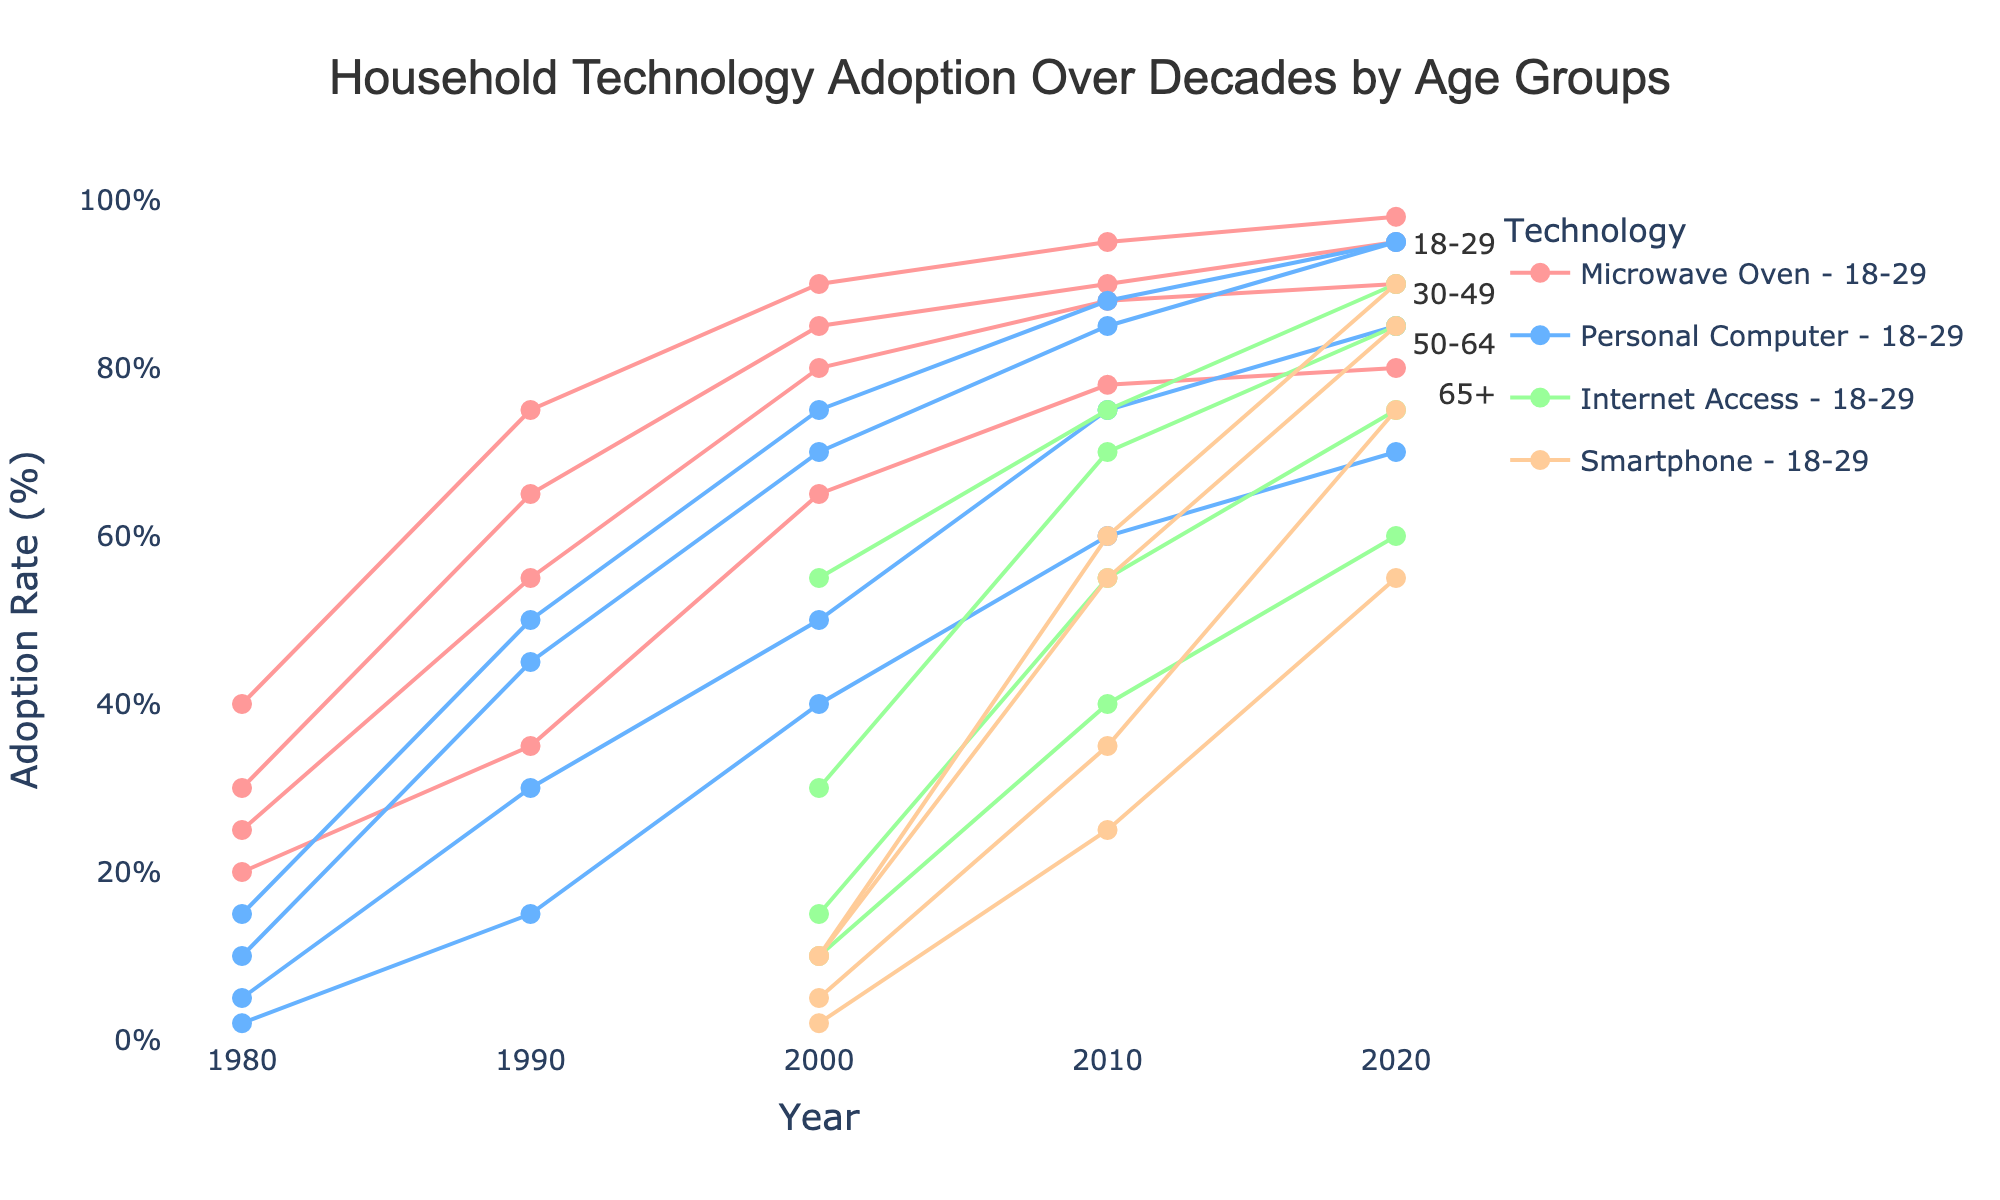What year shows the highest adoption rate for smartphones among 18-29-year-olds? By looking at the Ranged Dot Plot, identify the year label on the x-axis where the data point for 18-29-year-olds and smartphones is at its highest position on the y-axis.
Answer: 2020 What is the main title of the figure? Locate the text at the top center of the plot to find the main title.
Answer: Household Technology Adoption Over Decades by Age Groups Which technology had the lowest adoption rate in 2000 within the 65+ age group? Look at the data points for each technology in the year 2000 corresponding to the 65+ age group. Identify the one with the lowest position on the y-axis.
Answer: Personal Computer How did the adoption rate of microwave ovens in the 30-49 age group change from 1980 to 2020? Find the data points for microwave ovens for the 30-49 age group in 1980 and 2020. Subtract the 1980 adoption rate from the 2020 adoption rate.
Answer: Increased by 58% What is the trend of internet access adoption among 50-64-year-olds from 2000 to 2020? Observe the positioning of the data points for internet access in the 50-64 age group in the years 2000, 2010, and 2020. Note whether the points rise, fall, or remain consistent.
Answer: Increasing Compare the adoption rates of personal computers and microwaves for the 18-29 age group in 1990. Look at the data points for personal computers and microwave ovens for the 18-29 age group in 1990. Compare their positions on the y-axis to determine which is higher or if they are equal.
Answer: Microwave Ovens are higher Which technology saw the greatest relative increase in the 50-64 age group from 2000 to 2020? Calculate the increase by finding the difference in adoption rates between 2000 and 2020 for each technology in the 50-64 age group. Identify the technology with the largest increase.
Answer: Smartphones In 2010, which age group had the highest adoption rate for internet access? Compare the positions of the data points for internet access in 2010 among all age groups. Identify the highest position on the y-axis.
Answer: 18-29 What was the adoption rate of personal computers for the 65+ age group in 1980? Find the data point on the plot for personal computers in the 65+ age group in 1980. Identify and record the adoption rate value.
Answer: 2% In what year did the 30-49 age group first show an adoption rate for smartphones? Locate when the first data point for smartphones appears for the 30-49 age group on the x-axis timeline.
Answer: 2000 